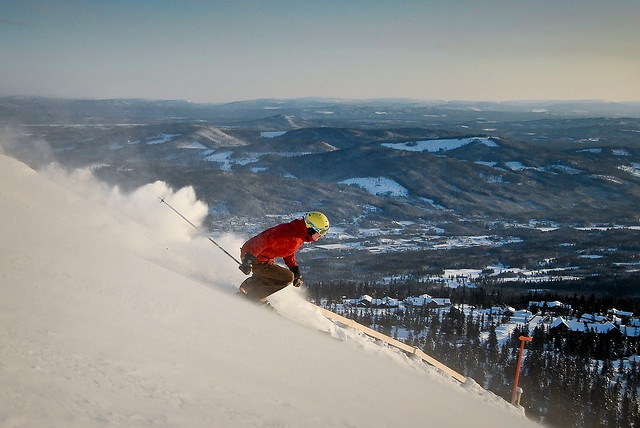Describe the objects in this image and their specific colors. I can see people in gray, maroon, and black tones, skis in gray, lightgray, and darkgray tones, and snowboard in darkgray, gray, and lightgray tones in this image. 